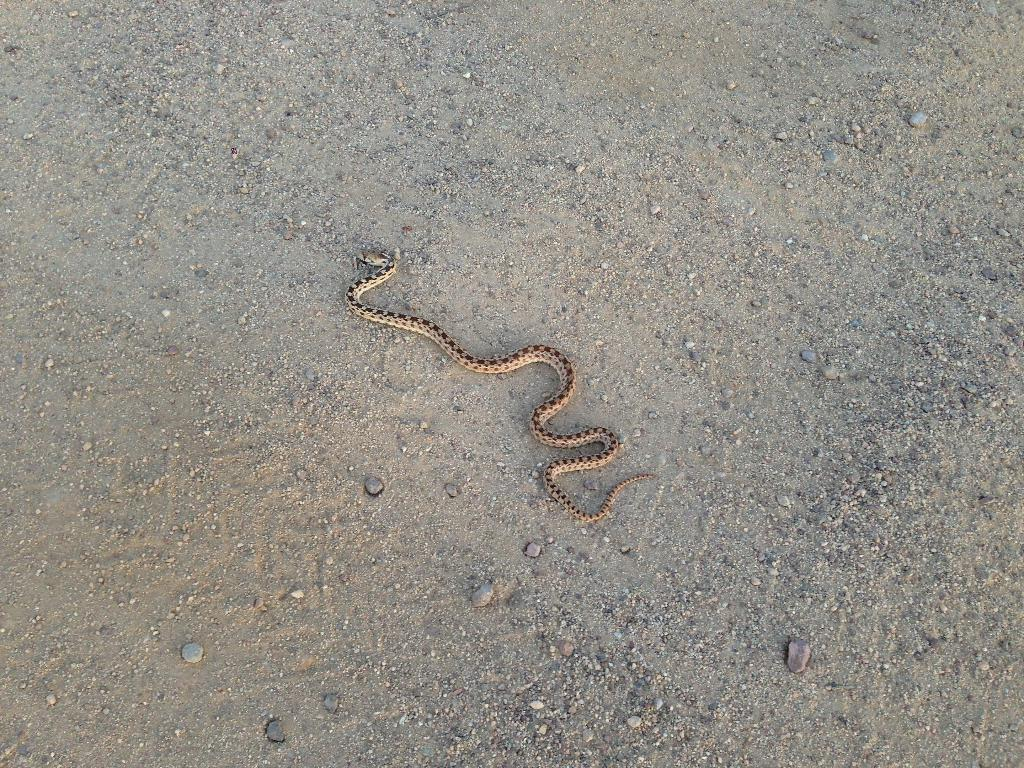What animal is present in the image? There is a snake in the image. What type of terrain is the snake on? The snake is on the sand. What can be seen at the bottom of the image? There is mud at the bottom of the image. What other objects are present in the image? There are stones in the image. How many planes can be seen flying over the snake in the image? There are no planes visible in the image; it only features a snake on the sand, mud at the bottom, and stones. What type of breath does the snake have in the image? Snakes do not have visible breath, and there is no indication of any breathing in the image. 